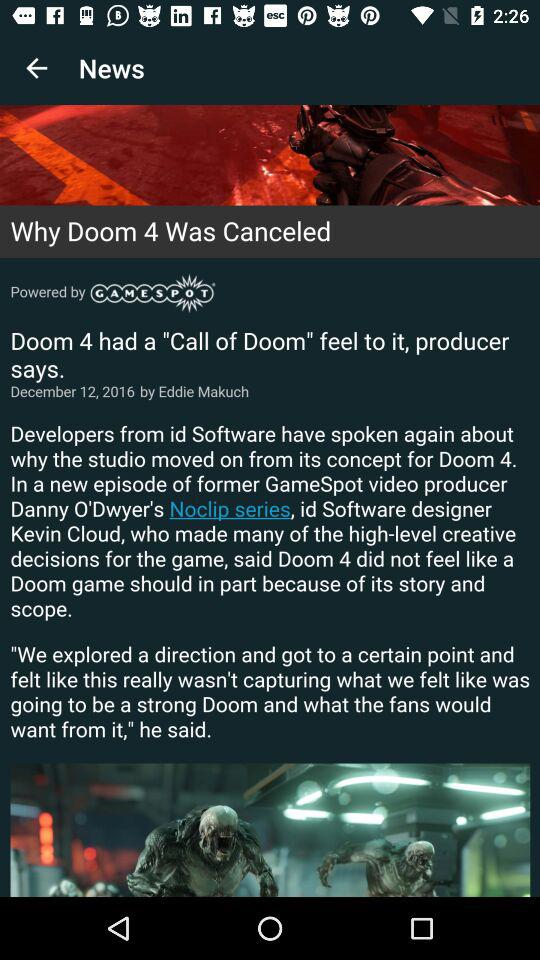What is the title of the headline? The title of the headline is "Why Doom 4 Was Canceled". 